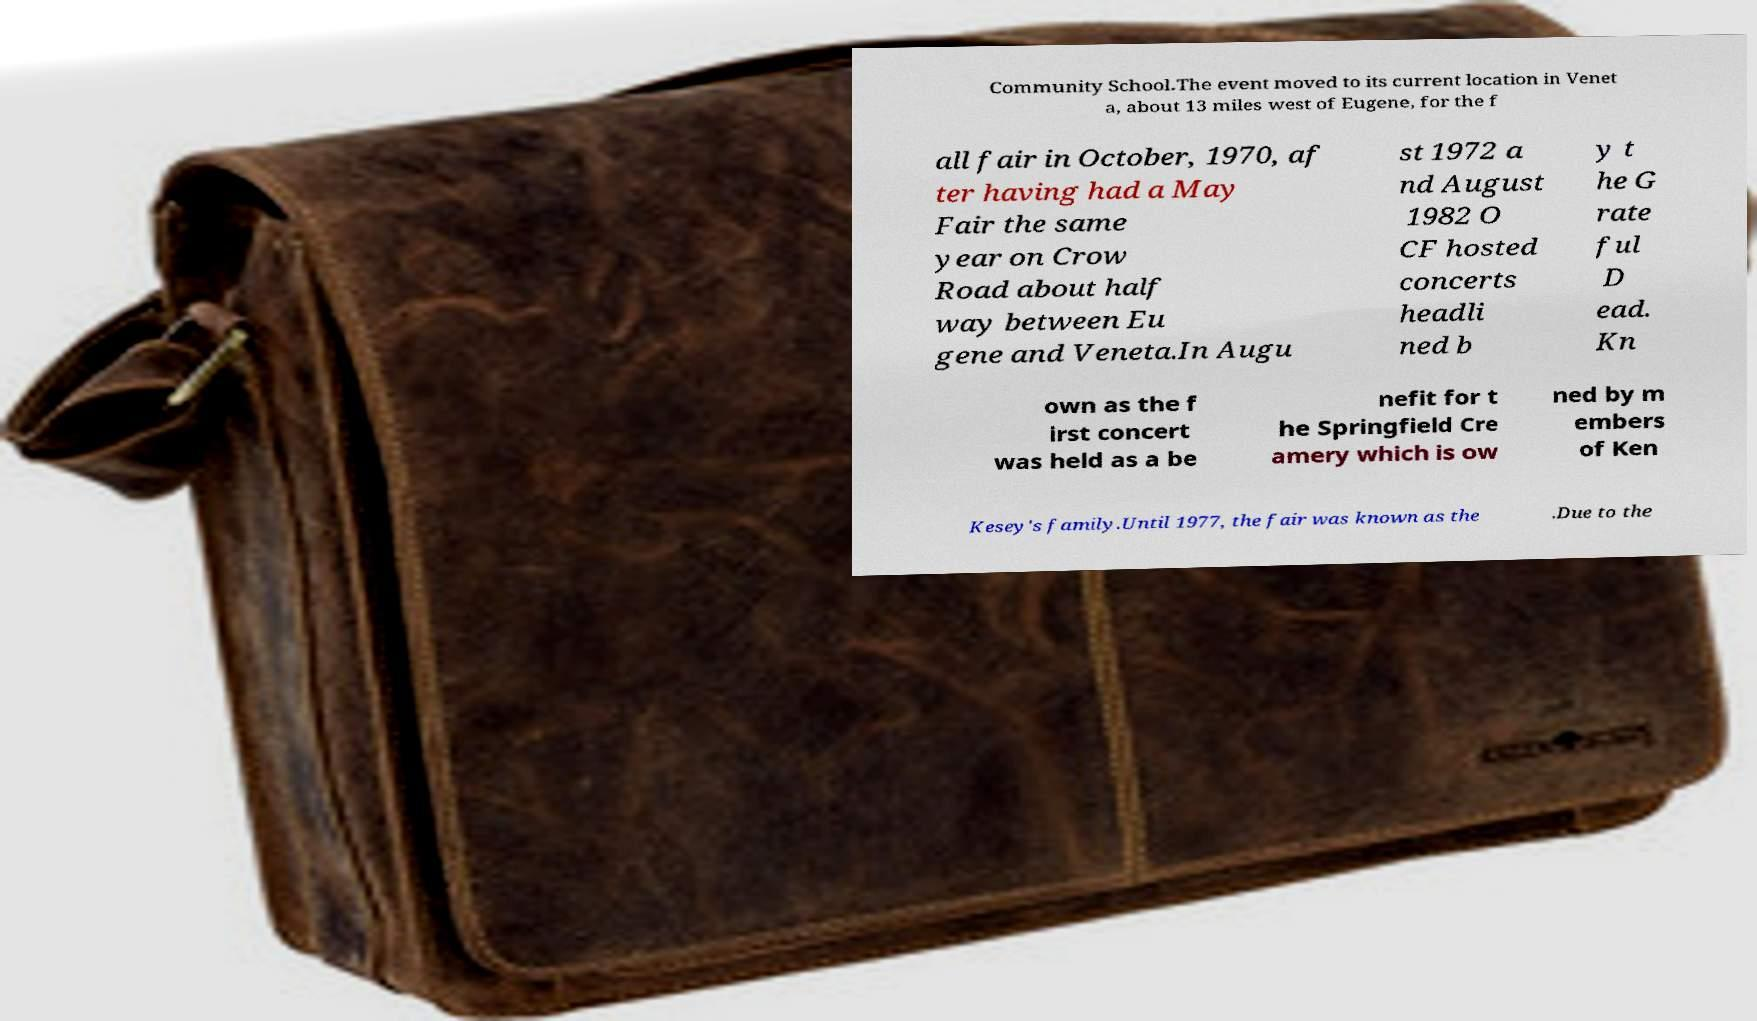Please identify and transcribe the text found in this image. Community School.The event moved to its current location in Venet a, about 13 miles west of Eugene, for the f all fair in October, 1970, af ter having had a May Fair the same year on Crow Road about half way between Eu gene and Veneta.In Augu st 1972 a nd August 1982 O CF hosted concerts headli ned b y t he G rate ful D ead. Kn own as the f irst concert was held as a be nefit for t he Springfield Cre amery which is ow ned by m embers of Ken Kesey's family.Until 1977, the fair was known as the .Due to the 